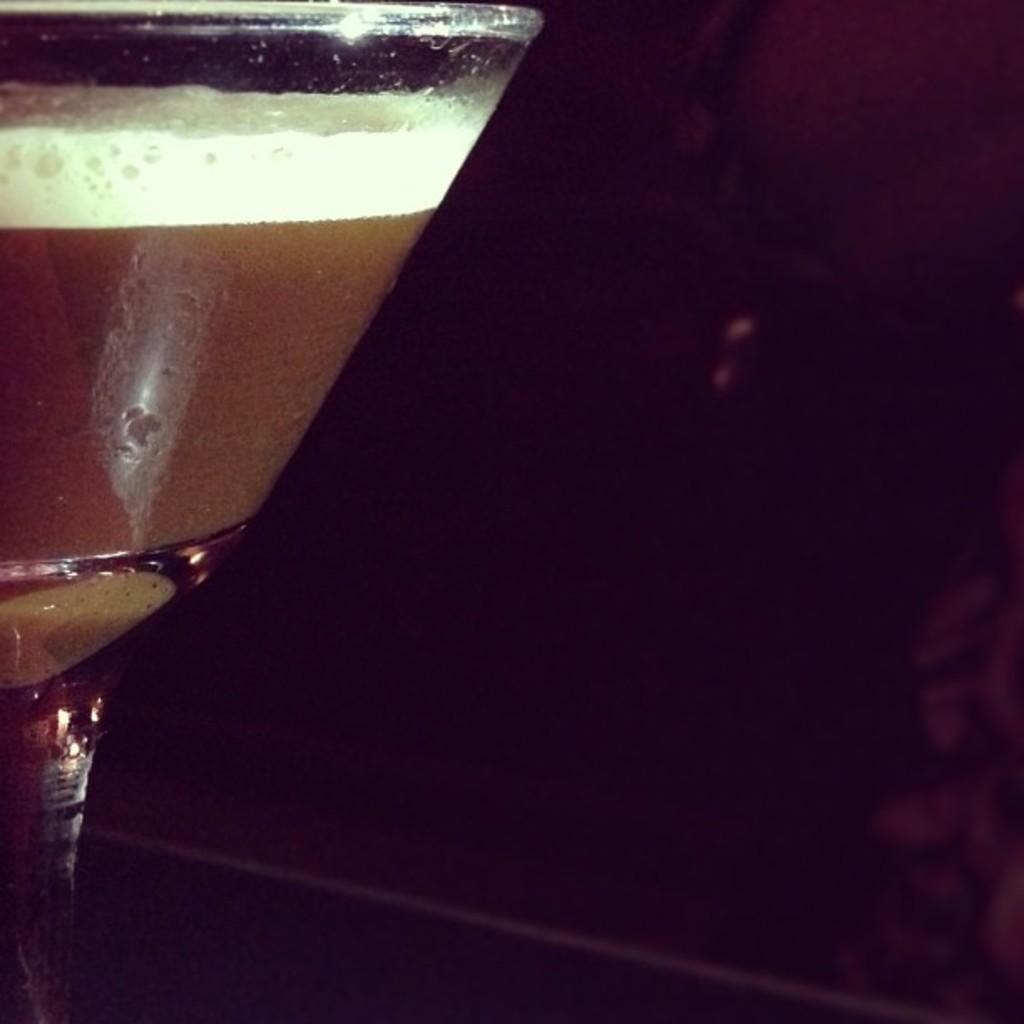Can you describe this image briefly? In this image in the foreground there is one glass and in the glass there is some drink, and the background is black in color. 